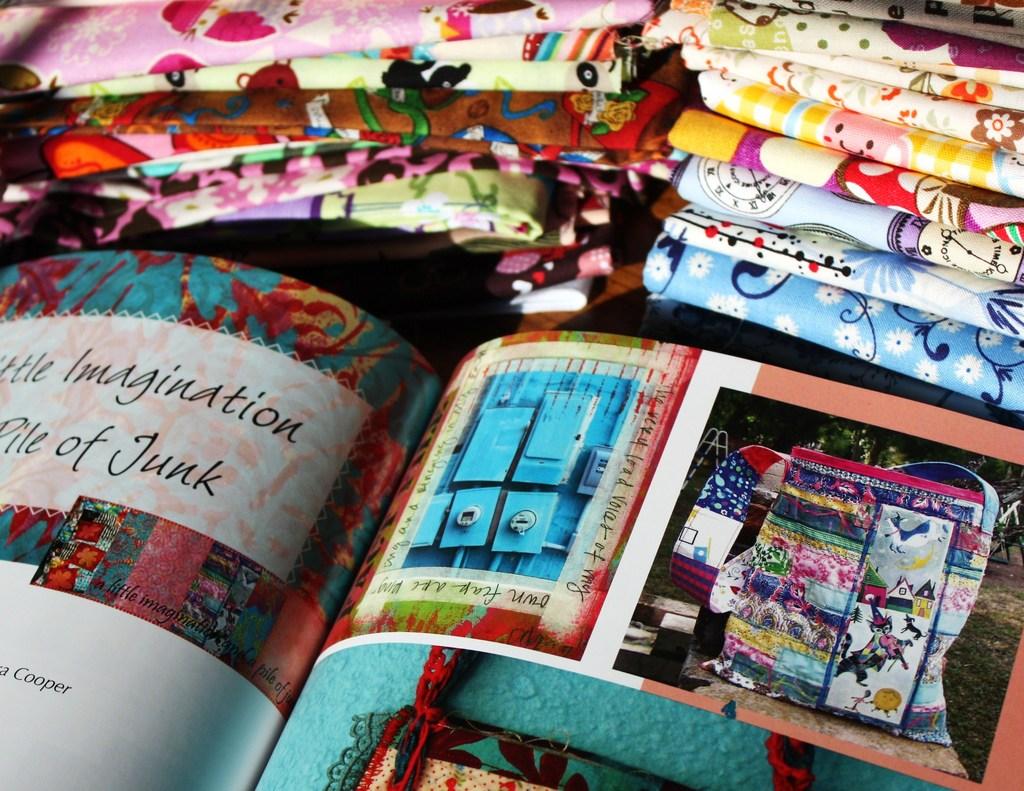What should we use when looking at the junk?
Your response must be concise. Imagination. 